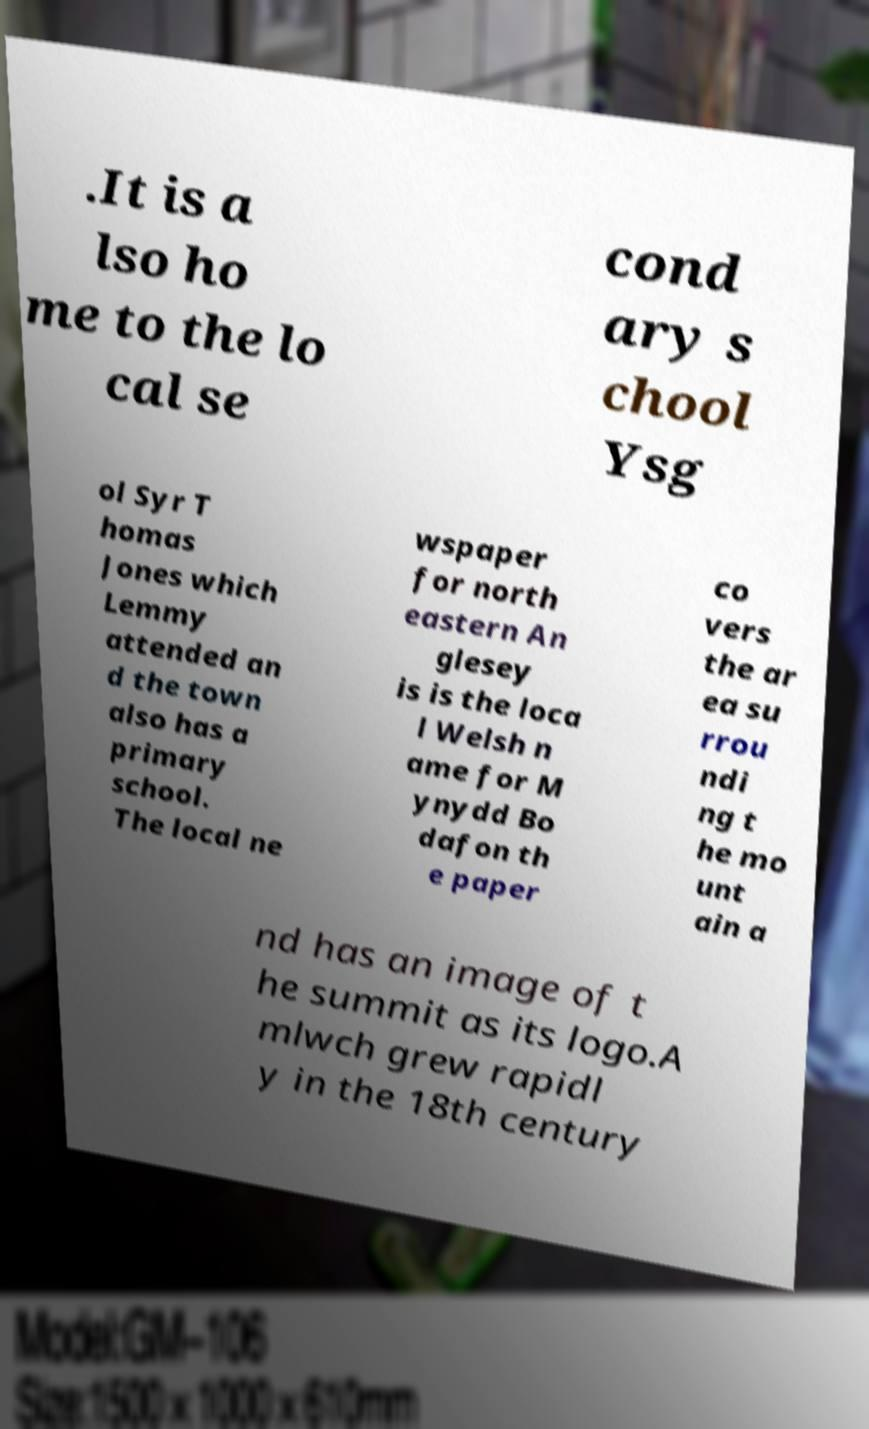Please read and relay the text visible in this image. What does it say? .It is a lso ho me to the lo cal se cond ary s chool Ysg ol Syr T homas Jones which Lemmy attended an d the town also has a primary school. The local ne wspaper for north eastern An glesey is is the loca l Welsh n ame for M ynydd Bo dafon th e paper co vers the ar ea su rrou ndi ng t he mo unt ain a nd has an image of t he summit as its logo.A mlwch grew rapidl y in the 18th century 